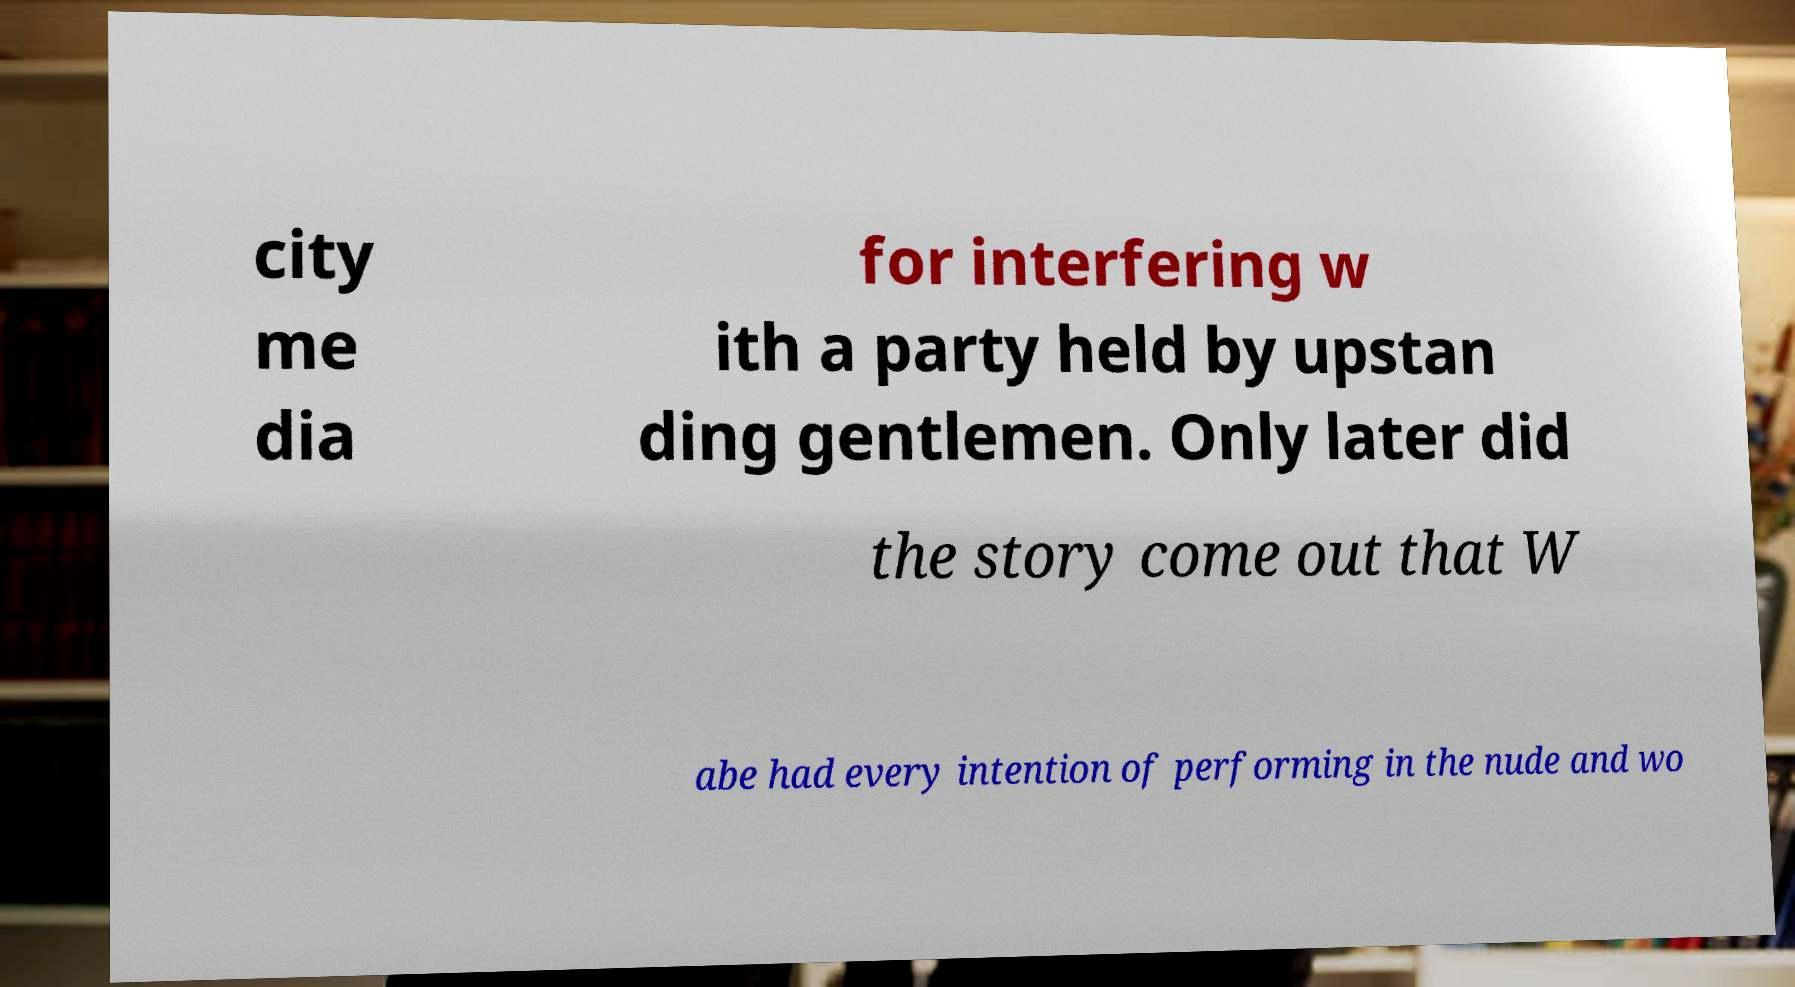Please read and relay the text visible in this image. What does it say? city me dia for interfering w ith a party held by upstan ding gentlemen. Only later did the story come out that W abe had every intention of performing in the nude and wo 